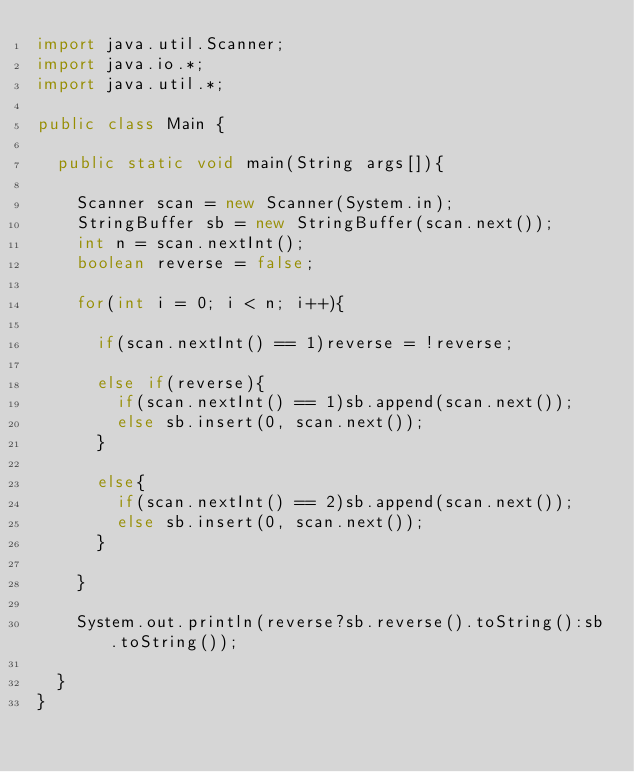<code> <loc_0><loc_0><loc_500><loc_500><_Java_>import java.util.Scanner;
import java.io.*;
import java.util.*;

public class Main {

	public static void main(String args[]){

		Scanner scan = new Scanner(System.in);
		StringBuffer sb = new StringBuffer(scan.next());
		int n = scan.nextInt();
		boolean reverse = false;

		for(int i = 0; i < n; i++){

			if(scan.nextInt() == 1)reverse = !reverse; 

			else if(reverse){
				if(scan.nextInt() == 1)sb.append(scan.next());
				else sb.insert(0, scan.next());
			}
			
			else{
				if(scan.nextInt() == 2)sb.append(scan.next());
				else sb.insert(0, scan.next());
			}

		}

		System.out.println(reverse?sb.reverse().toString():sb.toString());

	}
}</code> 